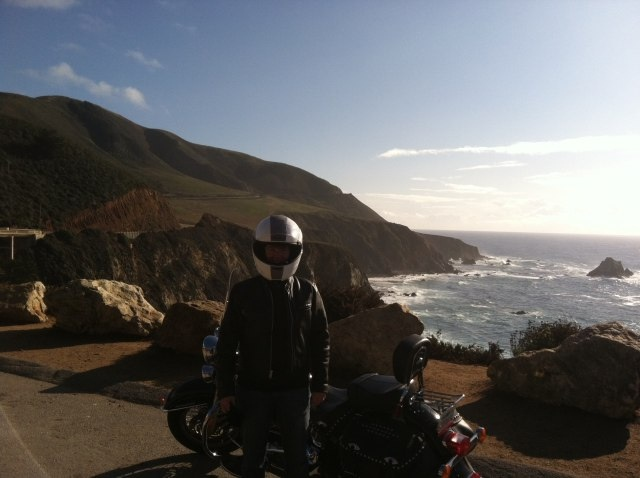Describe the objects in this image and their specific colors. I can see motorcycle in gray, black, and maroon tones and people in gray and black tones in this image. 